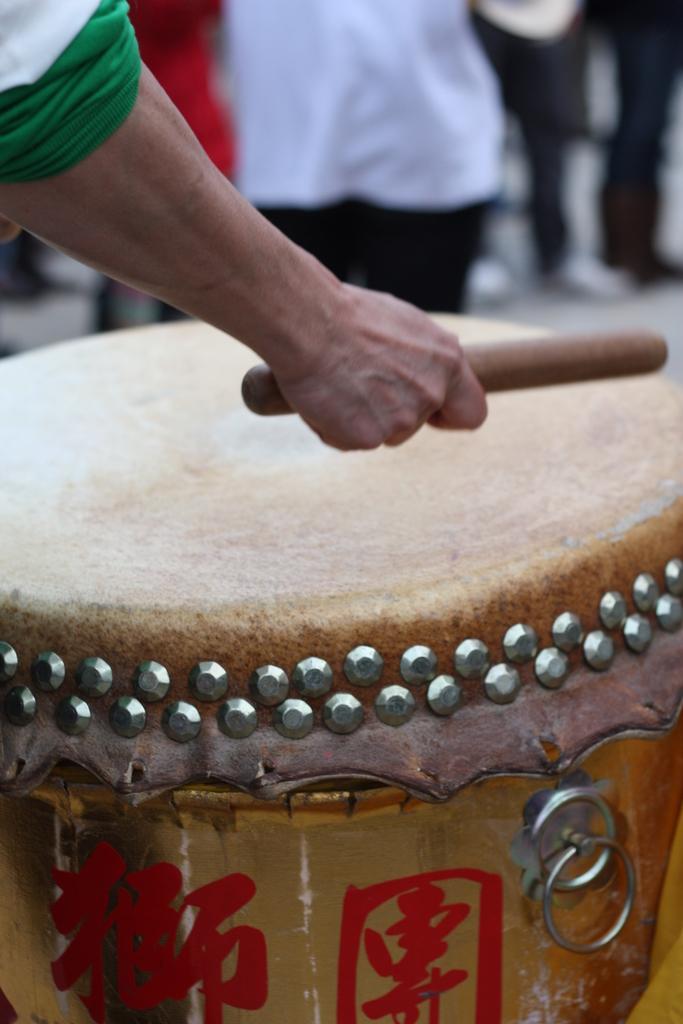Can you describe this image briefly? In this image there is a person who is holding the drumstick. In front of him there is a drum. There is a painting on the drum and there are pins all around it. In the background there are few people standing on the ground. 